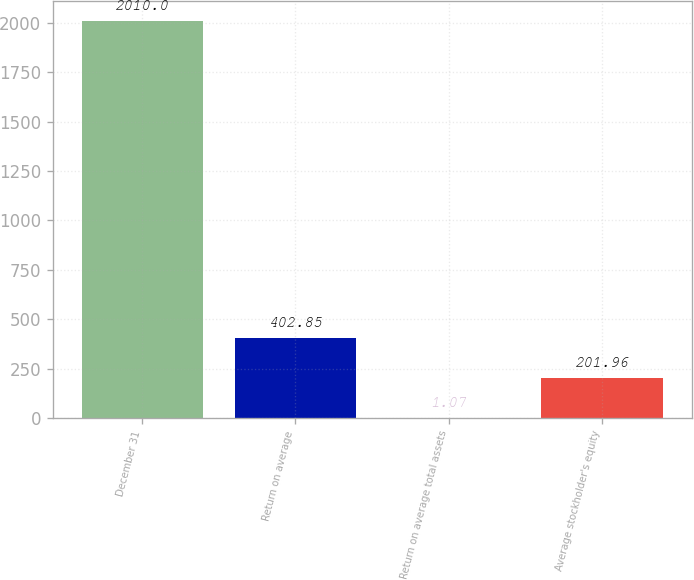<chart> <loc_0><loc_0><loc_500><loc_500><bar_chart><fcel>December 31<fcel>Return on average<fcel>Return on average total assets<fcel>Average stockholder's equity<nl><fcel>2010<fcel>402.85<fcel>1.07<fcel>201.96<nl></chart> 